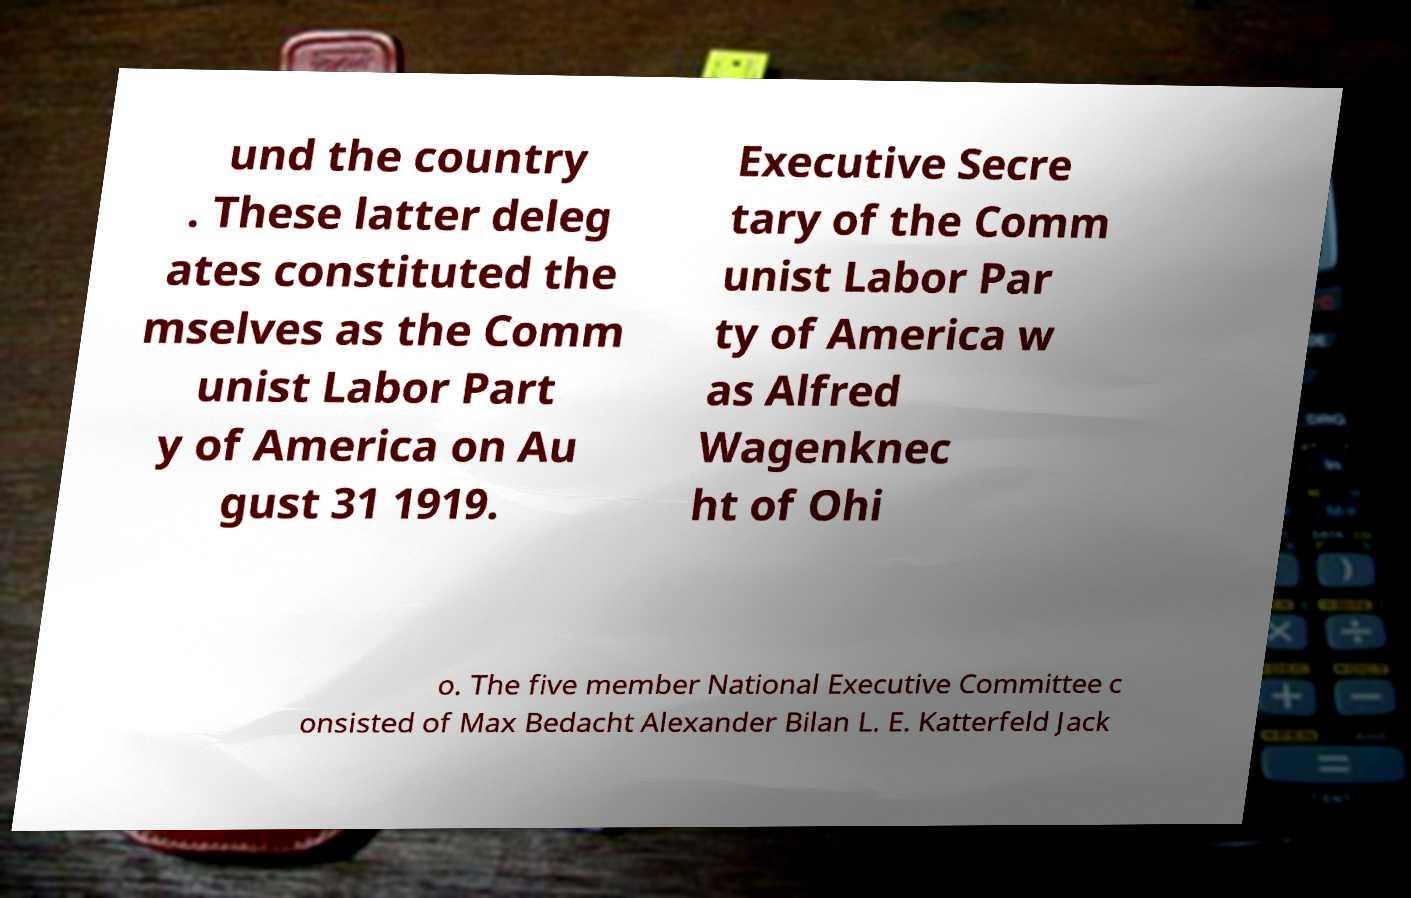Can you read and provide the text displayed in the image?This photo seems to have some interesting text. Can you extract and type it out for me? und the country . These latter deleg ates constituted the mselves as the Comm unist Labor Part y of America on Au gust 31 1919. Executive Secre tary of the Comm unist Labor Par ty of America w as Alfred Wagenknec ht of Ohi o. The five member National Executive Committee c onsisted of Max Bedacht Alexander Bilan L. E. Katterfeld Jack 